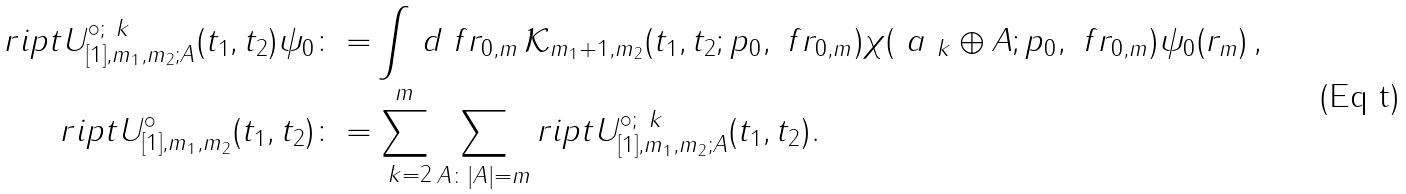<formula> <loc_0><loc_0><loc_500><loc_500>r i p t U ^ { \circ ; \ k } _ { [ 1 ] , m _ { 1 } , m _ { 2 } ; A } ( t _ { 1 } , t _ { 2 } ) \psi _ { 0 } \colon = & \int \, d \ f r _ { 0 , m } \, \mathcal { K } _ { m _ { 1 } + 1 , m _ { 2 } } ( t _ { 1 } , t _ { 2 } ; p _ { 0 } , \ f r _ { 0 , m } ) \chi ( \ a _ { \ k } \oplus A ; p _ { 0 } , \ f r _ { 0 , m } ) \psi _ { 0 } ( r _ { m } ) \, , \\ r i p t U ^ { \circ } _ { [ 1 ] , m _ { 1 } , m _ { 2 } } ( t _ { 1 } , t _ { 2 } ) \colon = & \sum _ { \ k = 2 } ^ { m } \sum _ { A \colon | A | = m } r i p t U ^ { \circ ; \ k } _ { [ 1 ] , m _ { 1 } , m _ { 2 } ; A } ( t _ { 1 } , t _ { 2 } ) .</formula> 